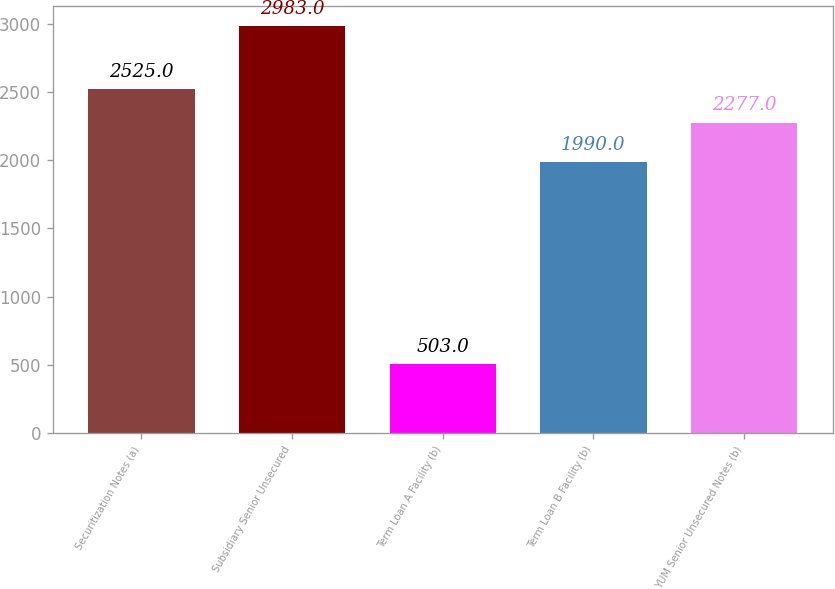Convert chart. <chart><loc_0><loc_0><loc_500><loc_500><bar_chart><fcel>Securitization Notes (a)<fcel>Subsidiary Senior Unsecured<fcel>Term Loan A Facility (b)<fcel>Term Loan B Facility (b)<fcel>YUM Senior Unsecured Notes (b)<nl><fcel>2525<fcel>2983<fcel>503<fcel>1990<fcel>2277<nl></chart> 